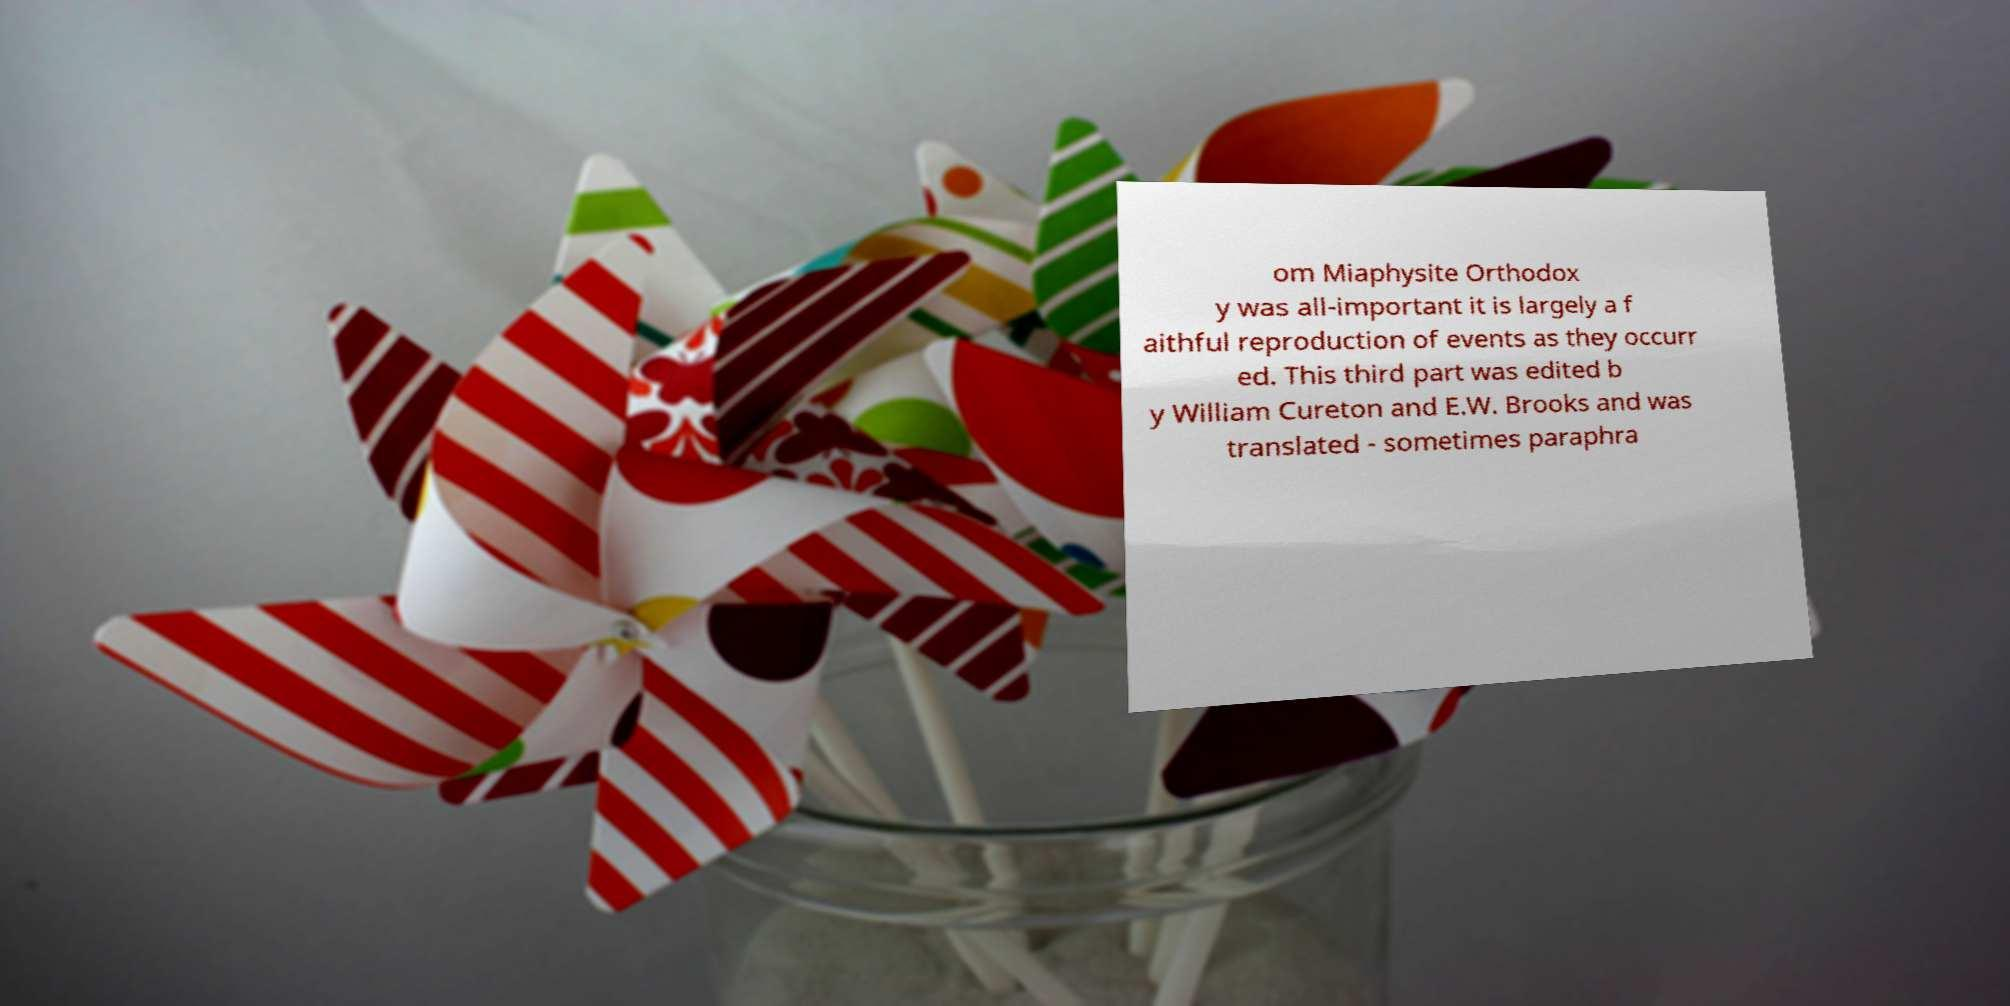Could you extract and type out the text from this image? om Miaphysite Orthodox y was all-important it is largely a f aithful reproduction of events as they occurr ed. This third part was edited b y William Cureton and E.W. Brooks and was translated - sometimes paraphra 